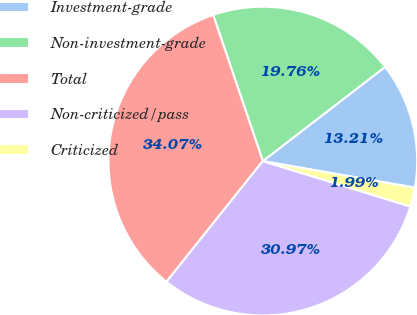Convert chart. <chart><loc_0><loc_0><loc_500><loc_500><pie_chart><fcel>Investment-grade<fcel>Non-investment-grade<fcel>Total<fcel>Non-criticized/pass<fcel>Criticized<nl><fcel>13.21%<fcel>19.76%<fcel>34.07%<fcel>30.97%<fcel>1.99%<nl></chart> 